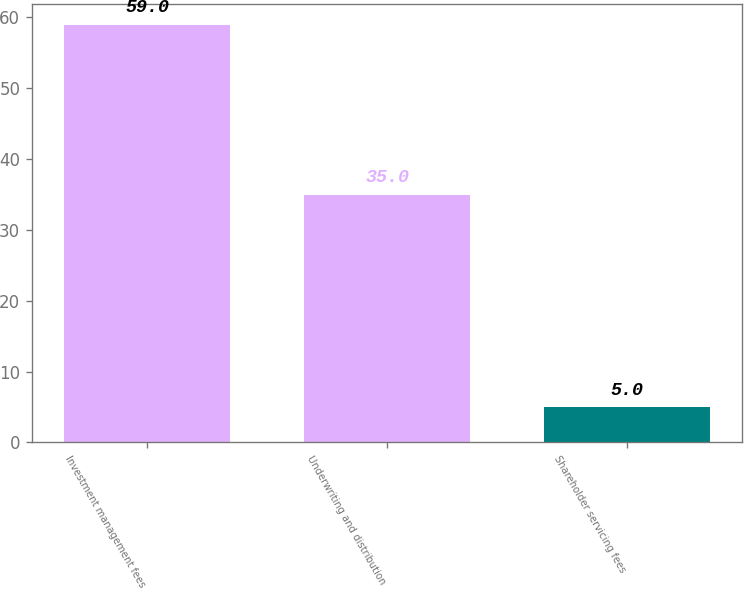Convert chart to OTSL. <chart><loc_0><loc_0><loc_500><loc_500><bar_chart><fcel>Investment management fees<fcel>Underwriting and distribution<fcel>Shareholder servicing fees<nl><fcel>59<fcel>35<fcel>5<nl></chart> 